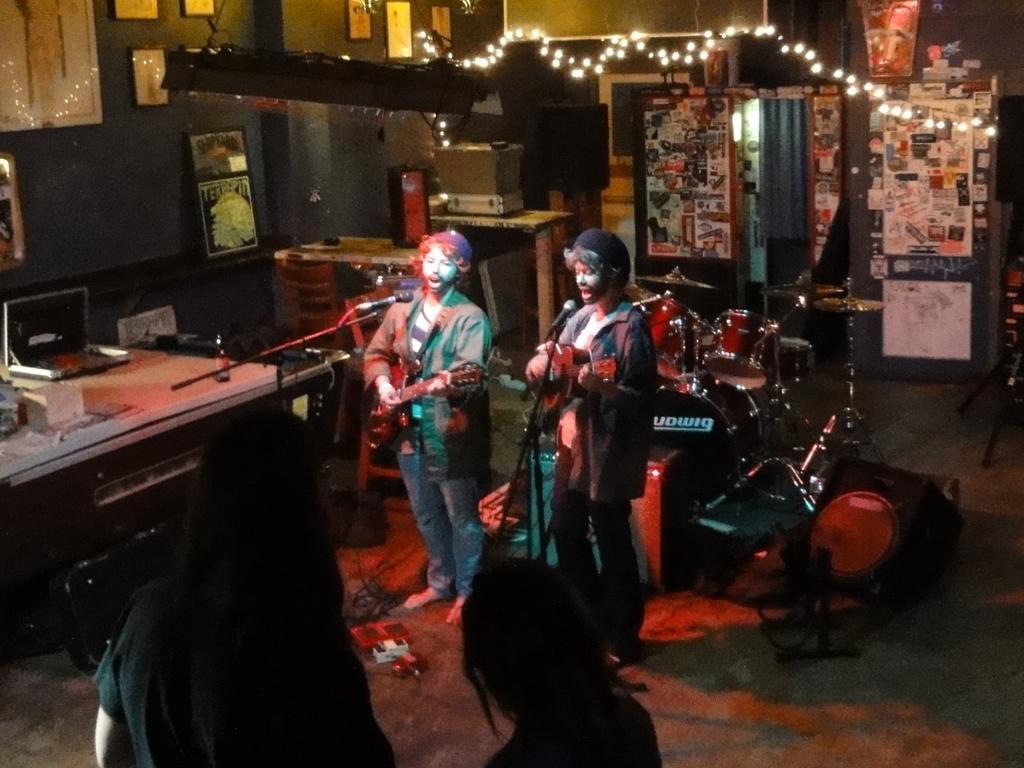Describe this image in one or two sentences. In this picture we can see a room in which there are two people holding guitars and standing in front of the mics in between the room and behind them there are some musical instruments and to the left side of the picture there is a desk on which some things are placed and some frames on the wall and behind them there is a notice board on which some papers are pasted and some lights to the roof and two people in front of them. 